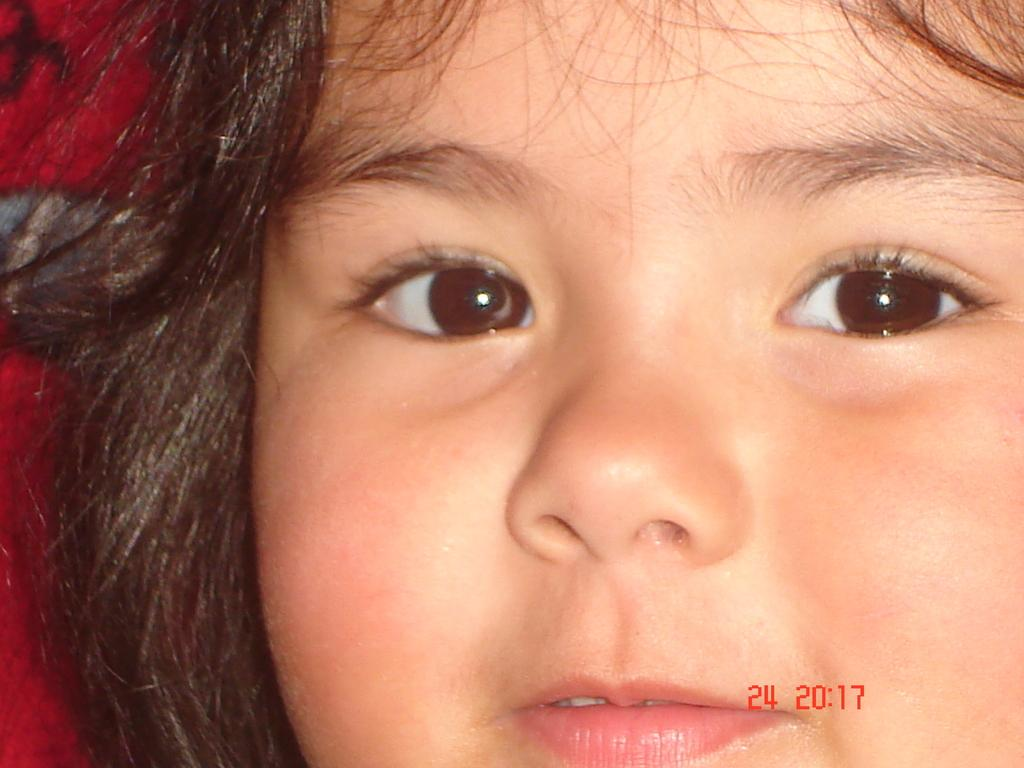What is the main subject of the image? The main subject of the image is the face of a child. Is there any text present in the image? Yes, there is some text at the bottom of the image. What type of art is displayed on the hydrant in the image? There is no hydrant present in the image, and therefore no art displayed on it. How many members are on the committee in the image? There is no committee present in the image. 